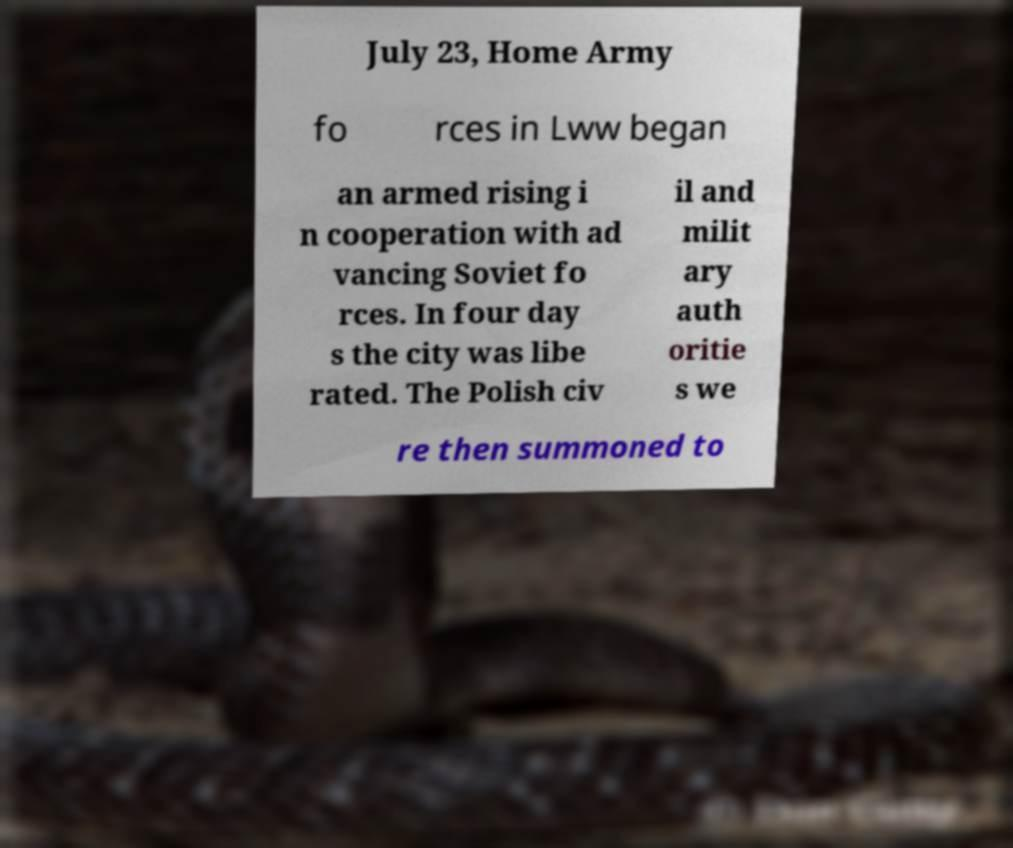I need the written content from this picture converted into text. Can you do that? July 23, Home Army fo rces in Lww began an armed rising i n cooperation with ad vancing Soviet fo rces. In four day s the city was libe rated. The Polish civ il and milit ary auth oritie s we re then summoned to 